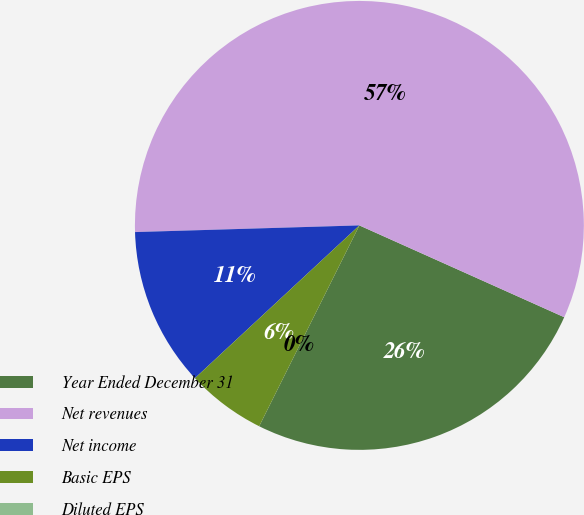Convert chart. <chart><loc_0><loc_0><loc_500><loc_500><pie_chart><fcel>Year Ended December 31<fcel>Net revenues<fcel>Net income<fcel>Basic EPS<fcel>Diluted EPS<nl><fcel>25.66%<fcel>57.18%<fcel>11.44%<fcel>5.72%<fcel>0.0%<nl></chart> 